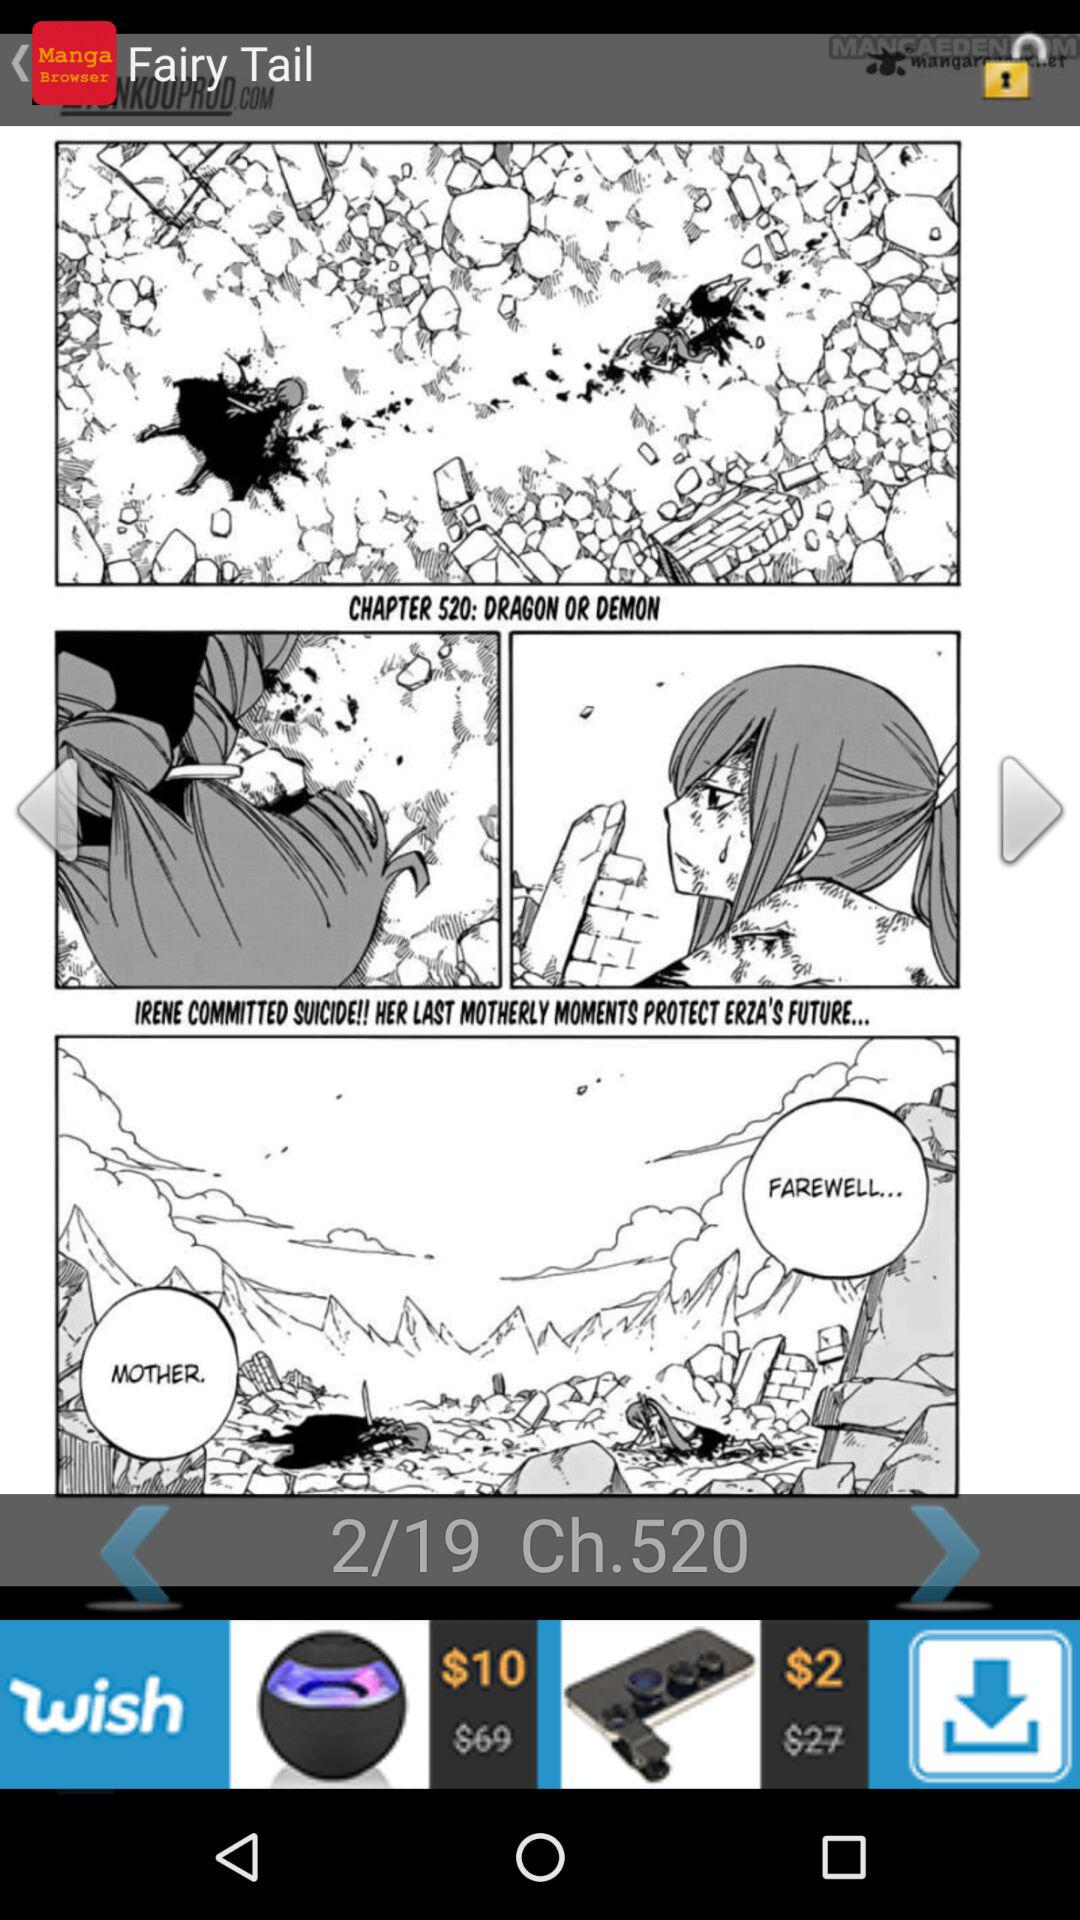What is the total number of slides? The total number of slides is 19. 